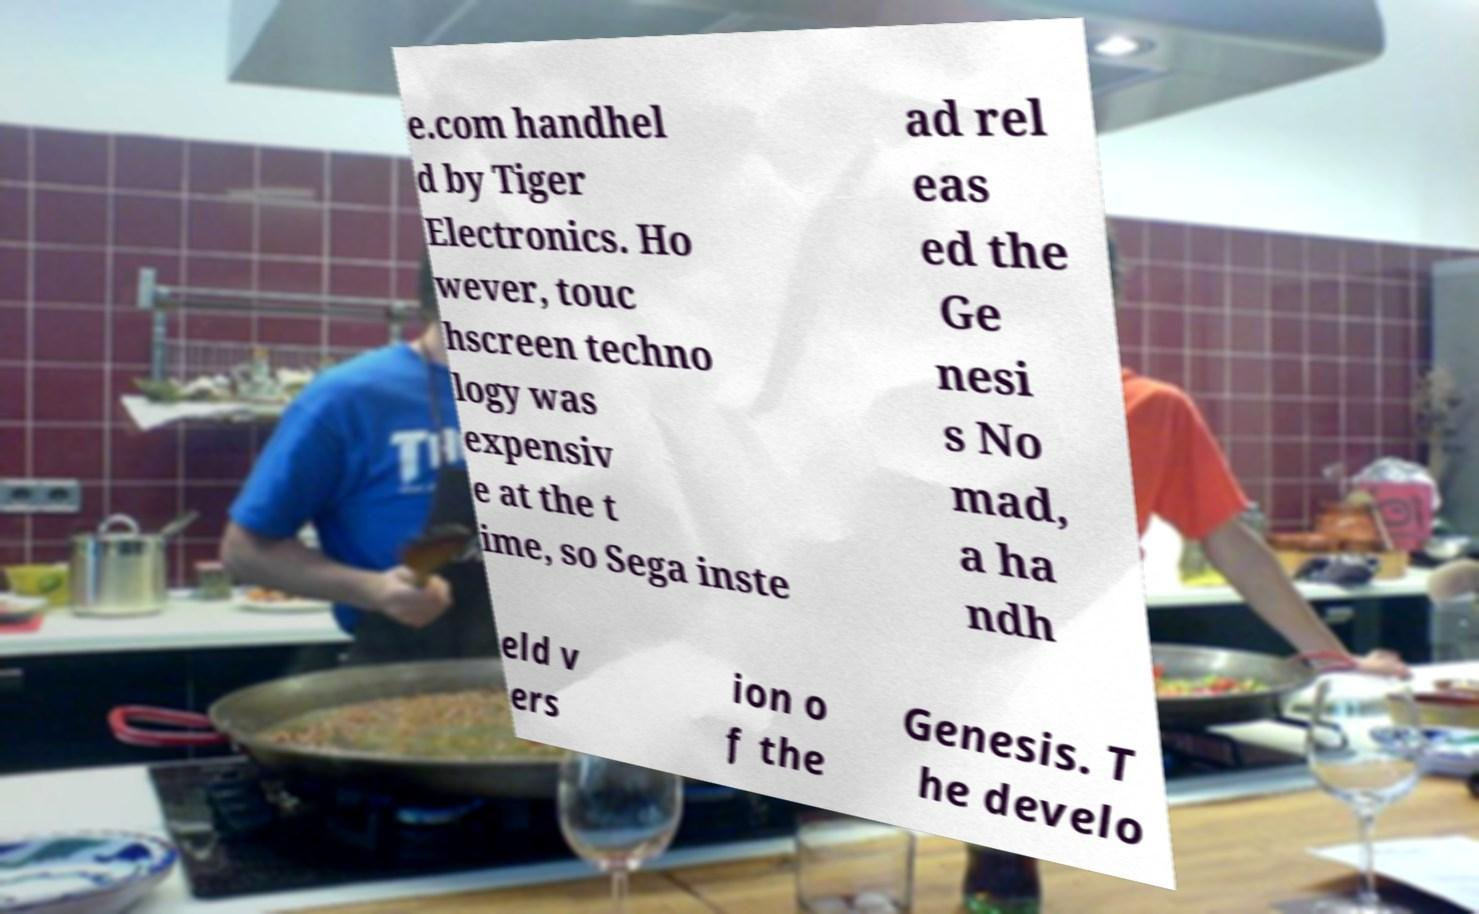For documentation purposes, I need the text within this image transcribed. Could you provide that? e.com handhel d by Tiger Electronics. Ho wever, touc hscreen techno logy was expensiv e at the t ime, so Sega inste ad rel eas ed the Ge nesi s No mad, a ha ndh eld v ers ion o f the Genesis. T he develo 